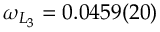<formula> <loc_0><loc_0><loc_500><loc_500>\omega _ { L _ { 3 } } = 0 . 0 4 5 9 ( 2 0 )</formula> 